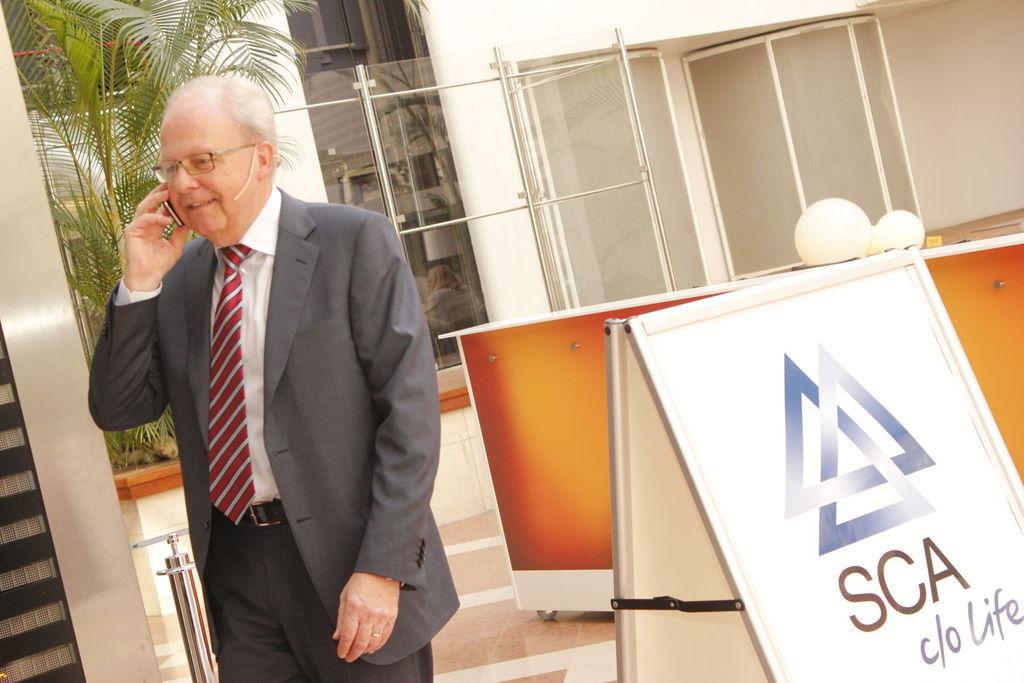How would you summarize this image in a sentence or two? This picture seems to be clicked inside the room. On the left there is a person wearing suit, standing and seems to be talking on a mobile phone. On the right we can see the text on the banner and we can see there are some objects placed on the top of the table. In the background we can see the wall, windows, house plant and some other objects. 